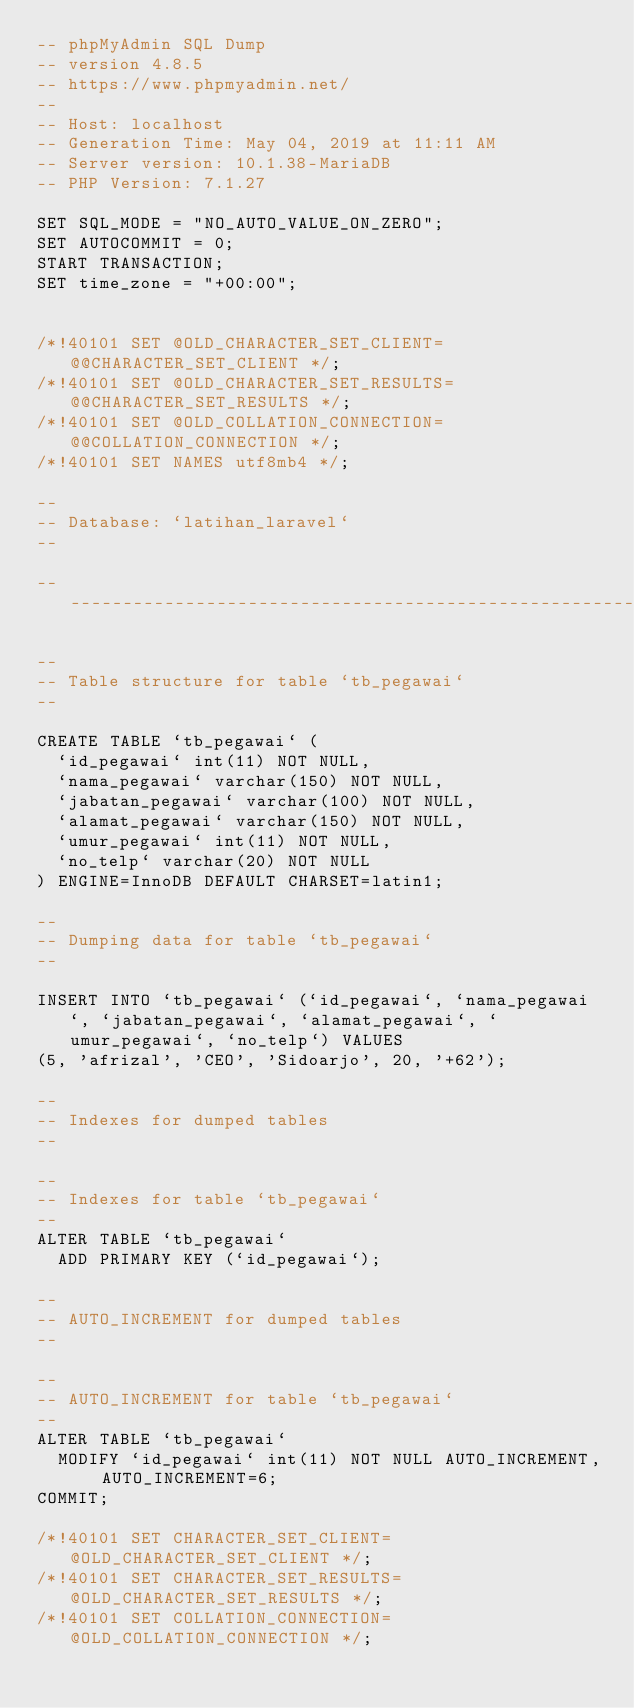Convert code to text. <code><loc_0><loc_0><loc_500><loc_500><_SQL_>-- phpMyAdmin SQL Dump
-- version 4.8.5
-- https://www.phpmyadmin.net/
--
-- Host: localhost
-- Generation Time: May 04, 2019 at 11:11 AM
-- Server version: 10.1.38-MariaDB
-- PHP Version: 7.1.27

SET SQL_MODE = "NO_AUTO_VALUE_ON_ZERO";
SET AUTOCOMMIT = 0;
START TRANSACTION;
SET time_zone = "+00:00";


/*!40101 SET @OLD_CHARACTER_SET_CLIENT=@@CHARACTER_SET_CLIENT */;
/*!40101 SET @OLD_CHARACTER_SET_RESULTS=@@CHARACTER_SET_RESULTS */;
/*!40101 SET @OLD_COLLATION_CONNECTION=@@COLLATION_CONNECTION */;
/*!40101 SET NAMES utf8mb4 */;

--
-- Database: `latihan_laravel`
--

-- --------------------------------------------------------

--
-- Table structure for table `tb_pegawai`
--

CREATE TABLE `tb_pegawai` (
  `id_pegawai` int(11) NOT NULL,
  `nama_pegawai` varchar(150) NOT NULL,
  `jabatan_pegawai` varchar(100) NOT NULL,
  `alamat_pegawai` varchar(150) NOT NULL,
  `umur_pegawai` int(11) NOT NULL,
  `no_telp` varchar(20) NOT NULL
) ENGINE=InnoDB DEFAULT CHARSET=latin1;

--
-- Dumping data for table `tb_pegawai`
--

INSERT INTO `tb_pegawai` (`id_pegawai`, `nama_pegawai`, `jabatan_pegawai`, `alamat_pegawai`, `umur_pegawai`, `no_telp`) VALUES
(5, 'afrizal', 'CEO', 'Sidoarjo', 20, '+62');

--
-- Indexes for dumped tables
--

--
-- Indexes for table `tb_pegawai`
--
ALTER TABLE `tb_pegawai`
  ADD PRIMARY KEY (`id_pegawai`);

--
-- AUTO_INCREMENT for dumped tables
--

--
-- AUTO_INCREMENT for table `tb_pegawai`
--
ALTER TABLE `tb_pegawai`
  MODIFY `id_pegawai` int(11) NOT NULL AUTO_INCREMENT, AUTO_INCREMENT=6;
COMMIT;

/*!40101 SET CHARACTER_SET_CLIENT=@OLD_CHARACTER_SET_CLIENT */;
/*!40101 SET CHARACTER_SET_RESULTS=@OLD_CHARACTER_SET_RESULTS */;
/*!40101 SET COLLATION_CONNECTION=@OLD_COLLATION_CONNECTION */;
</code> 